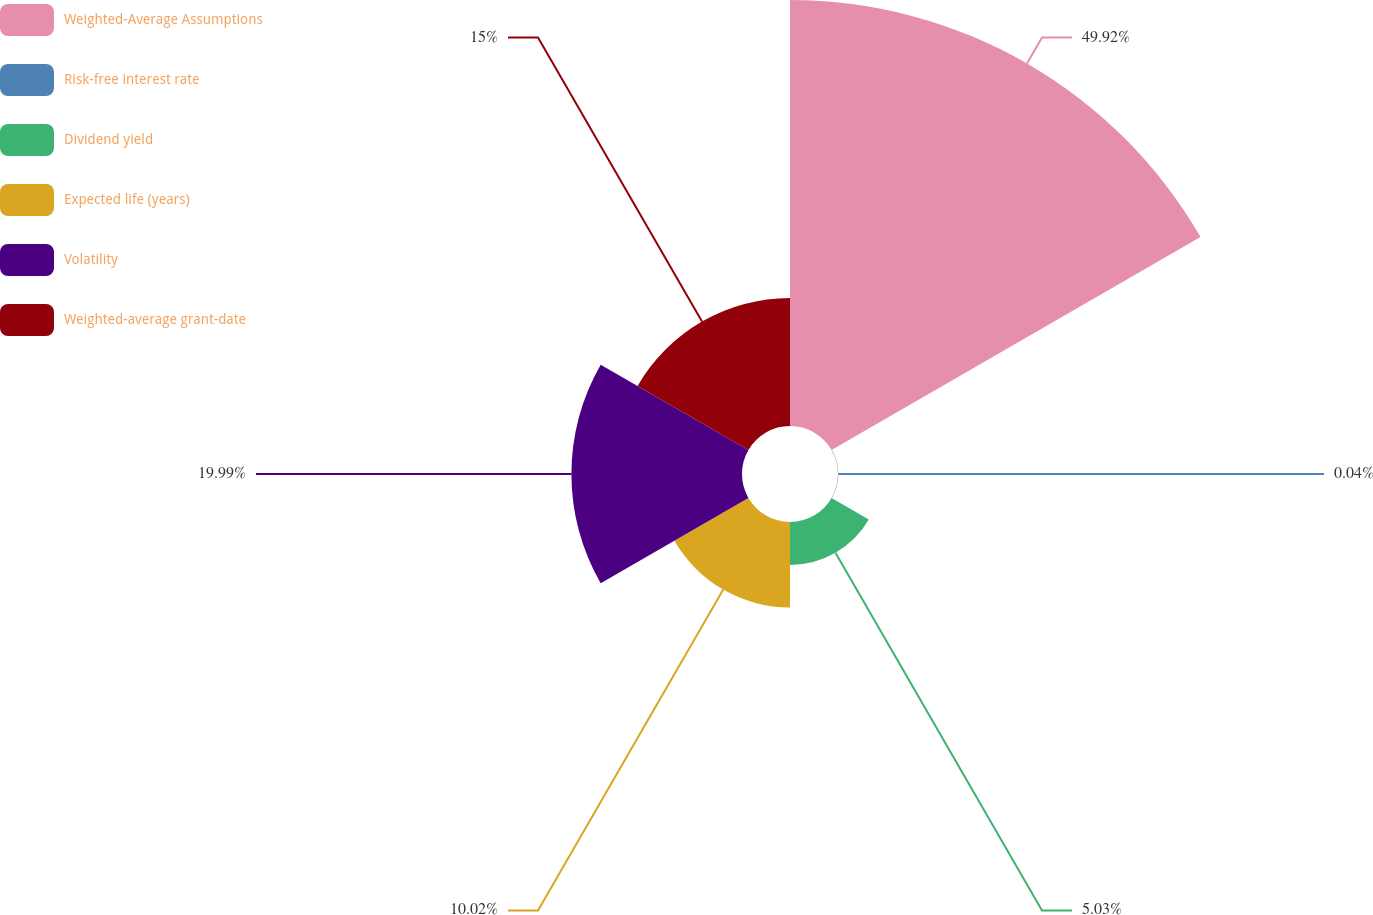Convert chart. <chart><loc_0><loc_0><loc_500><loc_500><pie_chart><fcel>Weighted-Average Assumptions<fcel>Risk-free interest rate<fcel>Dividend yield<fcel>Expected life (years)<fcel>Volatility<fcel>Weighted-average grant-date<nl><fcel>49.92%<fcel>0.04%<fcel>5.03%<fcel>10.02%<fcel>19.99%<fcel>15.0%<nl></chart> 